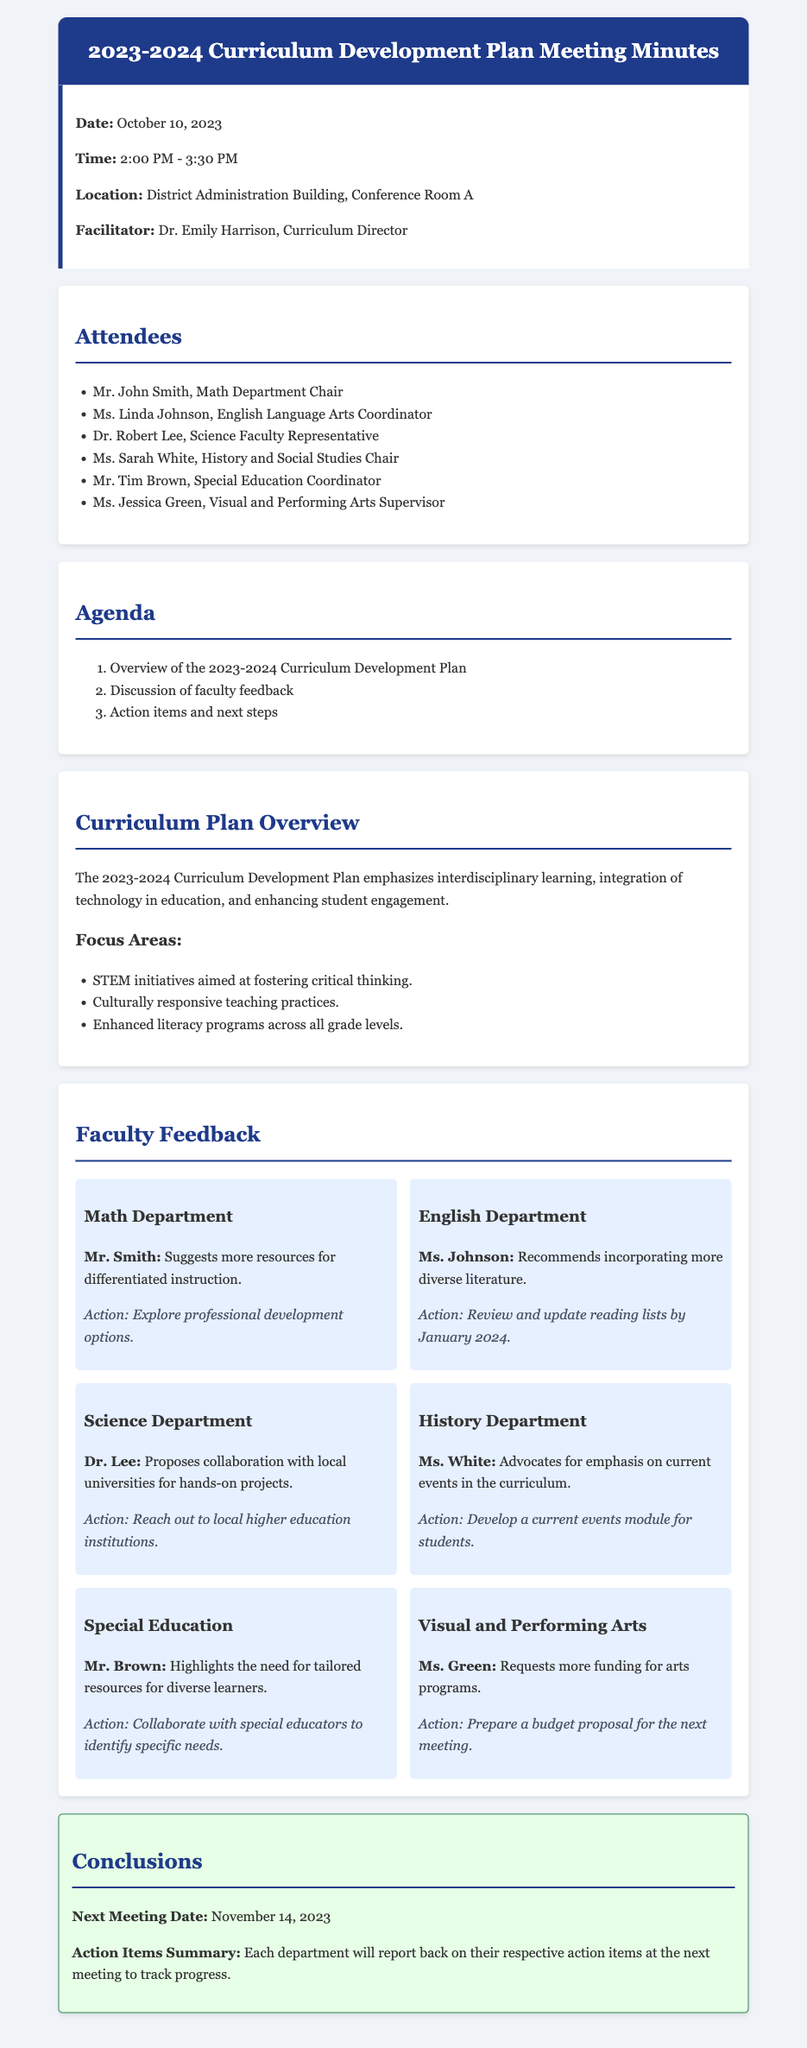What is the date of the meeting? The date of the meeting is explicitly mentioned in the document.
Answer: October 10, 2023 Who facilitated the meeting? The facilitator's name is provided in the meeting information section.
Answer: Dr. Emily Harrison What is one of the focus areas of the curriculum plan? The document lists several focus areas in the curriculum plan overview.
Answer: STEM initiatives What action is suggested for the Math Department? The action related to the Math Department's feedback is specified in the feedback section.
Answer: Explore professional development options When is the next meeting scheduled? The next meeting date is clearly indicated in the conclusions section.
Answer: November 14, 2023 Which department chair suggested incorporating more diverse literature? The document attributes this feedback to a specific faculty member.
Answer: Ms. Johnson How many attendees are listed in the document? The number of attendees can be counted from the attendance section of the minutes.
Answer: Six What is the purpose of developing a current events module? The reasoning behind the action item related to the History Department's feedback can be inferred from the document.
Answer: Emphasis on current events Which department needs tailored resources for diverse learners? The feedback item specifies this requirement for a particular department.
Answer: Special Education 